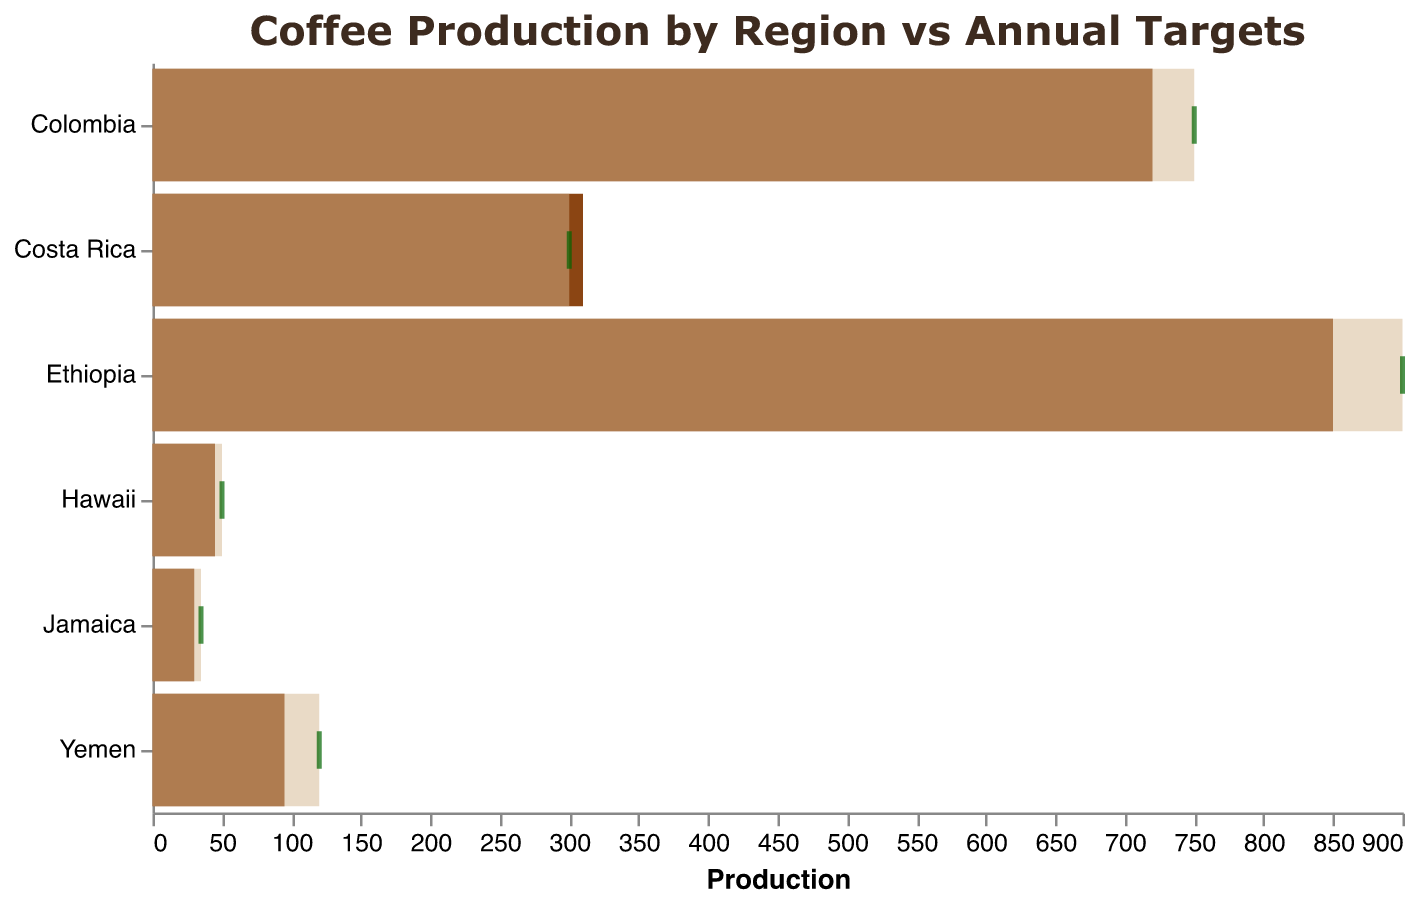What is the title of the chart? The title is located at the top of the chart and provides an overview of the content depicted.
Answer: Coffee Production by Region vs Annual Targets What color represents the actual production in the chart? By observing the color of the bars representing 'Actual' in the legend or the chart, it is clear that the actual production is depicted in a brown color.
Answer: brown Which region had the highest reported actual production? The regions are sorted with the highest to lowest actual production. The first bar represents the highest value.
Answer: Ethiopia Which regions successfully met or exceeded their annual targets? By comparing the 'Actual' bars to the 'Target' ticks for each region, any bar extending beyond or equal to its tick indicates successful target achievement. Therefore, Costa Rica is the only region that met its target.
Answer: Costa Rica How much coffee did Yemen produce compared to its target? By examining the position of Yemen's actual production bar and target tick: Actual (95) compared to Target (120), there's a shortfall. Subtract actual production from the target (120 - 95).
Answer: 25 units short What specialty coffee is associated with Jamaica? Tooltip information can be used to identify specialty types for each region, as visible when hovering over the respective bar. Jamaica associates with Blue Mountain Apiary.
Answer: Blue Mountain Apiary What is the difference in actual production between Ethiopia and Colombia? Check the actual production values for Ethiopia (850) and Colombia (720). Subtract Colombia's actual production from Ethiopia's.
Answer: 130 units Which region has the smallest difference between its actual production and its target? Calculate the differences between actual and target for each region. Costa Rica has the smallest difference (310 actual - 300 target = 10 units).
Answer: Costa Rica What color represents the annual targets in the chart? The annual targets are depicted in a lighter color with transparency, visible through the lighter/tan-colored background bars behind each actual production bar.
Answer: tan How many regions produced below their target? Compare the actual production bar length against the target tick for each region. Every bar falling short of the tick counts.
Answer: 5 regions 